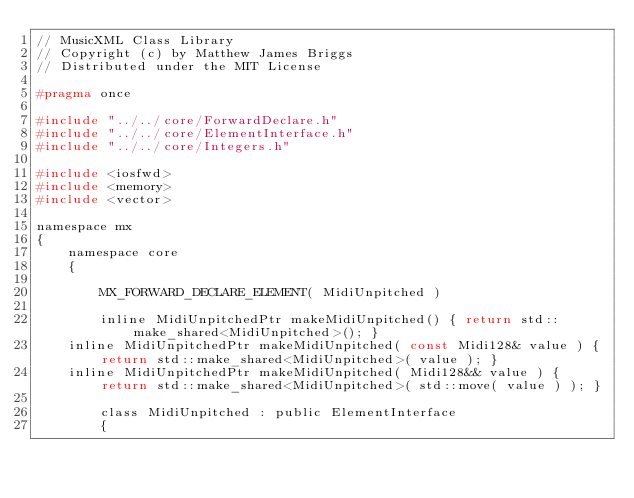Convert code to text. <code><loc_0><loc_0><loc_500><loc_500><_C_>// MusicXML Class Library
// Copyright (c) by Matthew James Briggs
// Distributed under the MIT License

#pragma once

#include "../../core/ForwardDeclare.h"
#include "../../core/ElementInterface.h"
#include "../../core/Integers.h"

#include <iosfwd>
#include <memory>
#include <vector>

namespace mx
{
    namespace core
    {

        MX_FORWARD_DECLARE_ELEMENT( MidiUnpitched )

        inline MidiUnpitchedPtr makeMidiUnpitched() { return std::make_shared<MidiUnpitched>(); }
		inline MidiUnpitchedPtr makeMidiUnpitched( const Midi128& value ) { return std::make_shared<MidiUnpitched>( value ); }
		inline MidiUnpitchedPtr makeMidiUnpitched( Midi128&& value ) { return std::make_shared<MidiUnpitched>( std::move( value ) ); }

        class MidiUnpitched : public ElementInterface
        {</code> 